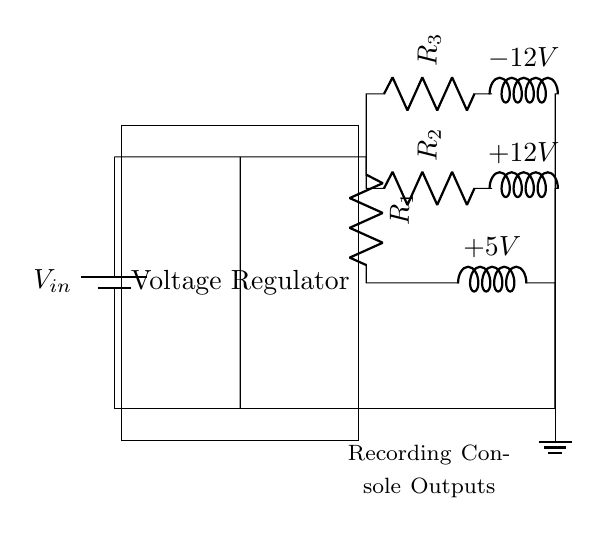What is the input voltage of the circuit? The input voltage is labeled as V_in at the battery in the circuit diagram.
Answer: V_in How many voltage outputs does the circuit provide? The circuit has three output paths, each delivering a different voltage: +5V, +12V, and -12V.
Answer: Three What component regulates the voltage in this circuit? The voltage regulator is the component responsible for adjusting the voltage before it reaches the output branches.
Answer: Voltage Regulator What are the resistance values in this circuit? The circuit includes three resistors labeled as R1, R2, and R3, but their specific resistance values are not provided in the diagram.
Answer: Unknown What is the total number of connections from the voltage regulator to the outputs? There are three distinct connections leading from the voltage regulator to the output branches for the respective voltage levels.
Answer: Three What kind of circuit is used for the power supply of the recording console? The circuit shown is a parallel circuit because all output branches are connected independently to the voltage supply, allowing multiple voltages.
Answer: Parallel Which direction do the grounds connect in this circuit? The ground connection is at the bottom of the circuit, where all the output branches ultimately return, ensuring a common reference point.
Answer: Bottom 